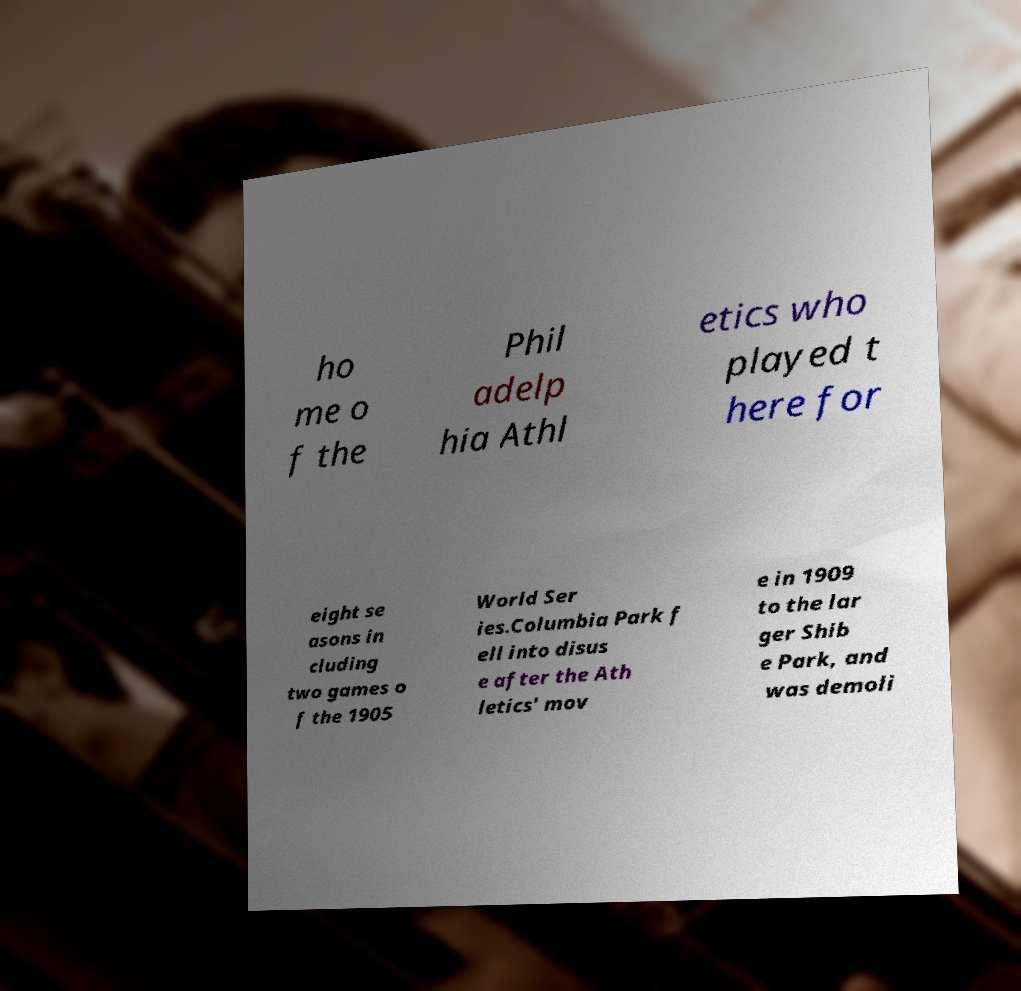For documentation purposes, I need the text within this image transcribed. Could you provide that? ho me o f the Phil adelp hia Athl etics who played t here for eight se asons in cluding two games o f the 1905 World Ser ies.Columbia Park f ell into disus e after the Ath letics' mov e in 1909 to the lar ger Shib e Park, and was demoli 